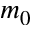Convert formula to latex. <formula><loc_0><loc_0><loc_500><loc_500>m _ { 0 }</formula> 